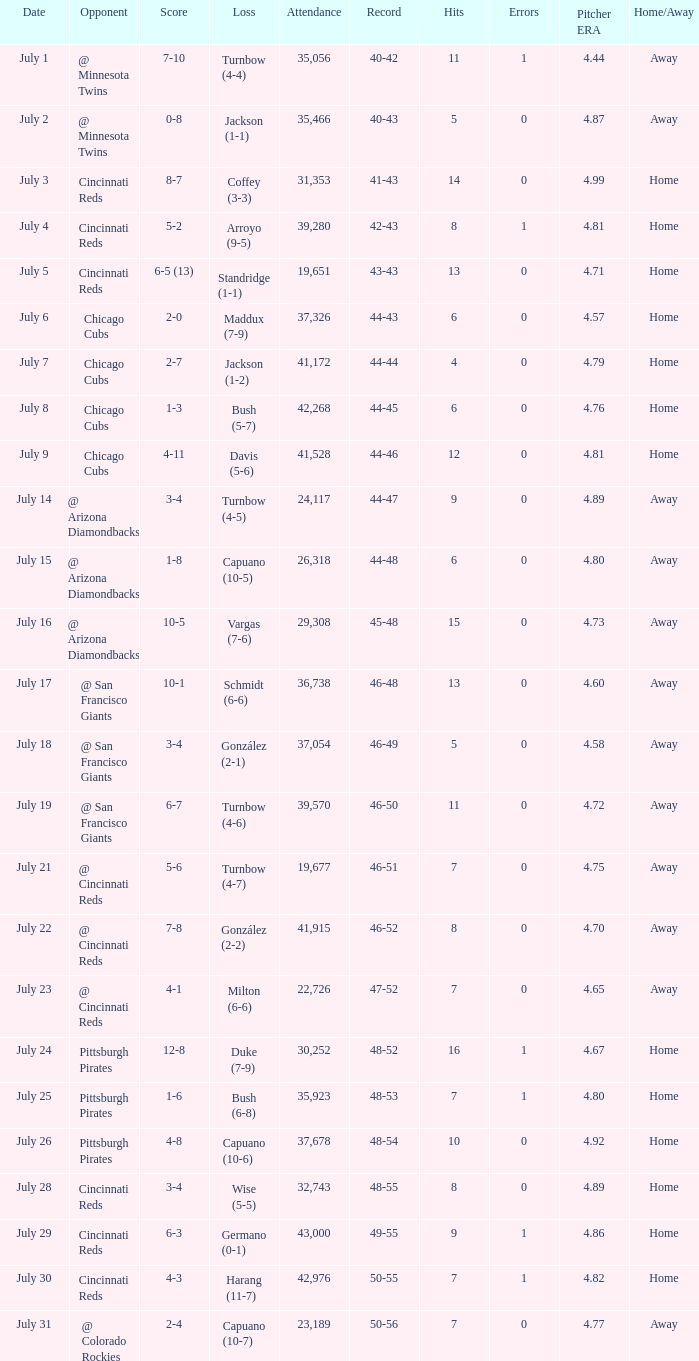What was the record at the game that had a score of 7-10? 40-42. 